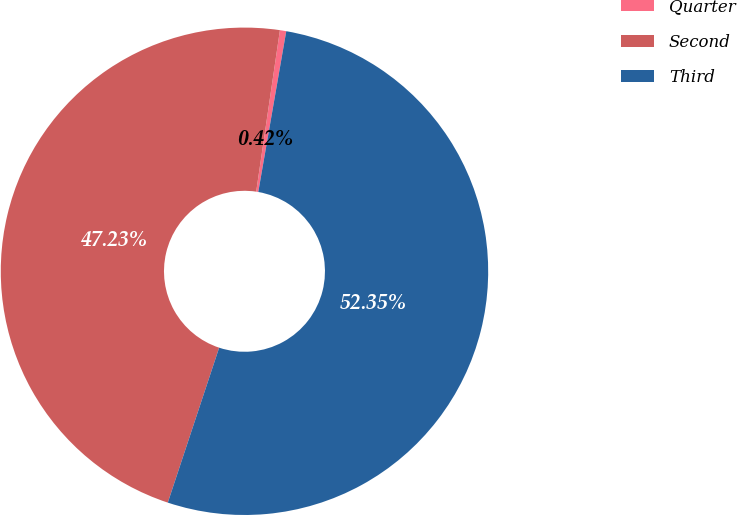<chart> <loc_0><loc_0><loc_500><loc_500><pie_chart><fcel>Quarter<fcel>Second<fcel>Third<nl><fcel>0.42%<fcel>47.23%<fcel>52.35%<nl></chart> 